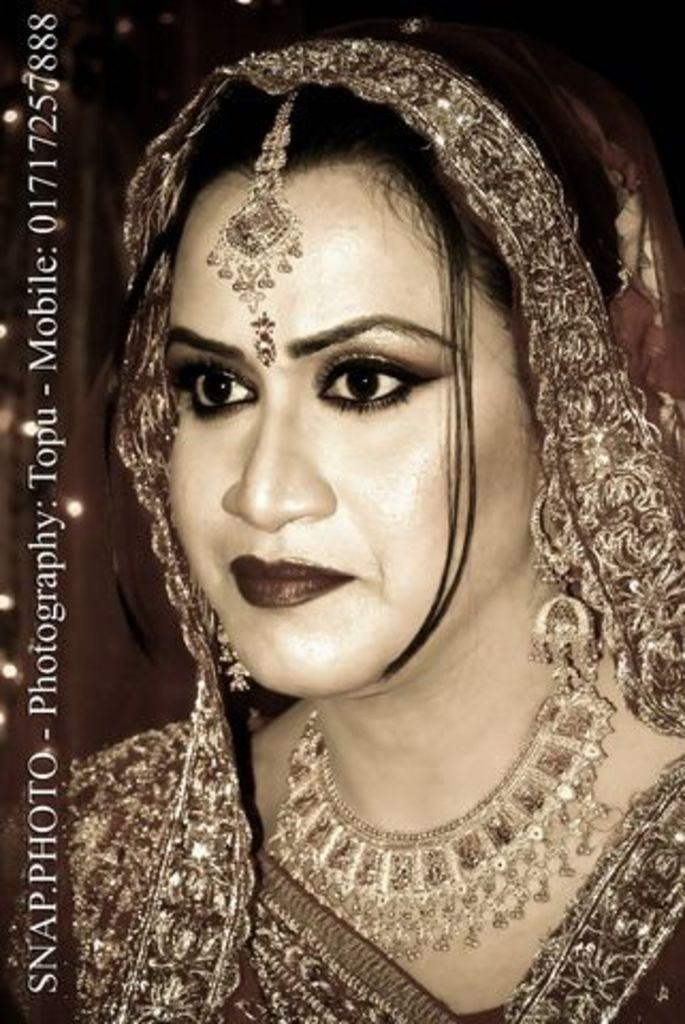What is the main subject of the image? The main subject of the image is a woman. Can you describe anything else present in the image? Yes, there is text on the left side of the image. How many cars can be seen in the image? There are no cars present in the image. What is the woman thinking about in the image? The image does not provide any information about the woman's thoughts. 